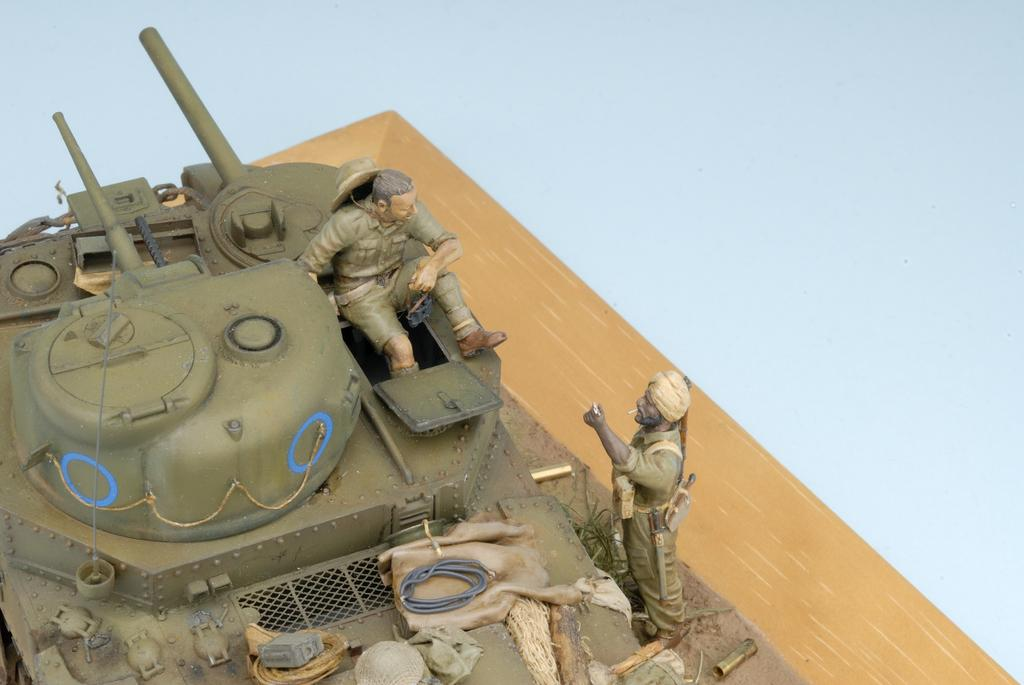What type of toys are present in the image? There are toy military tanks in the image. How many people are in the image? There are two persons in the image. Where are the toy military tanks and the two persons located? The toy military tanks and the two persons are on a table. What type of beetle can be seen accompanying the two persons on their journey in the image? There is no beetle present in the image, nor is there any indication of a journey. 